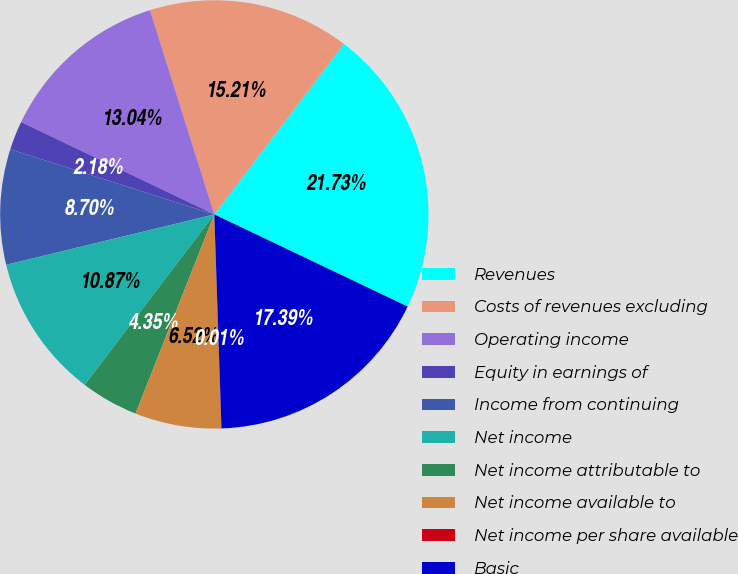Convert chart to OTSL. <chart><loc_0><loc_0><loc_500><loc_500><pie_chart><fcel>Revenues<fcel>Costs of revenues excluding<fcel>Operating income<fcel>Equity in earnings of<fcel>Income from continuing<fcel>Net income<fcel>Net income attributable to<fcel>Net income available to<fcel>Net income per share available<fcel>Basic<nl><fcel>21.73%<fcel>15.21%<fcel>13.04%<fcel>2.18%<fcel>8.7%<fcel>10.87%<fcel>4.35%<fcel>6.52%<fcel>0.01%<fcel>17.39%<nl></chart> 